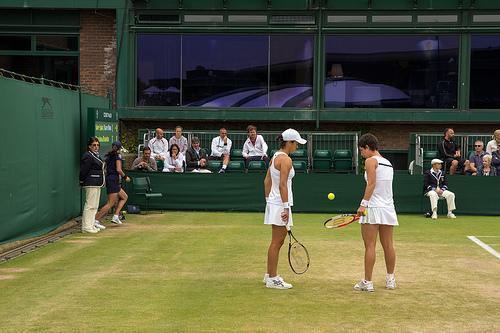How many women are playing?
Give a very brief answer. 2. 